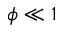Convert formula to latex. <formula><loc_0><loc_0><loc_500><loc_500>\phi \ll 1</formula> 